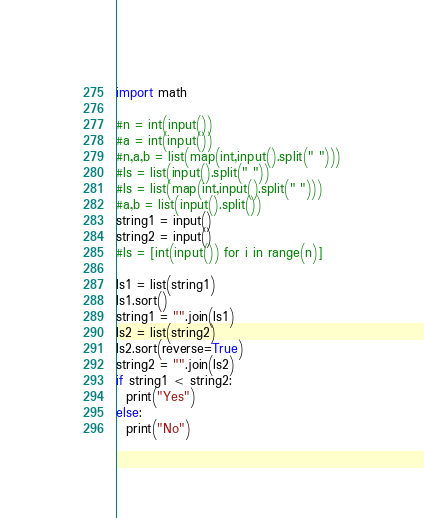<code> <loc_0><loc_0><loc_500><loc_500><_Python_>import math

#n = int(input())
#a = int(input())
#n,a,b = list(map(int,input().split(" ")))
#ls = list(input().split(" "))
#ls = list(map(int,input().split(" ")))
#a,b = list(input().split())
string1 = input()
string2 = input()
#ls = [int(input()) for i in range(n)]

ls1 = list(string1)
ls1.sort()
string1 = "".join(ls1)
ls2 = list(string2)
ls2.sort(reverse=True)
string2 = "".join(ls2)
if string1 < string2:
  print("Yes")
else:
  print("No")</code> 